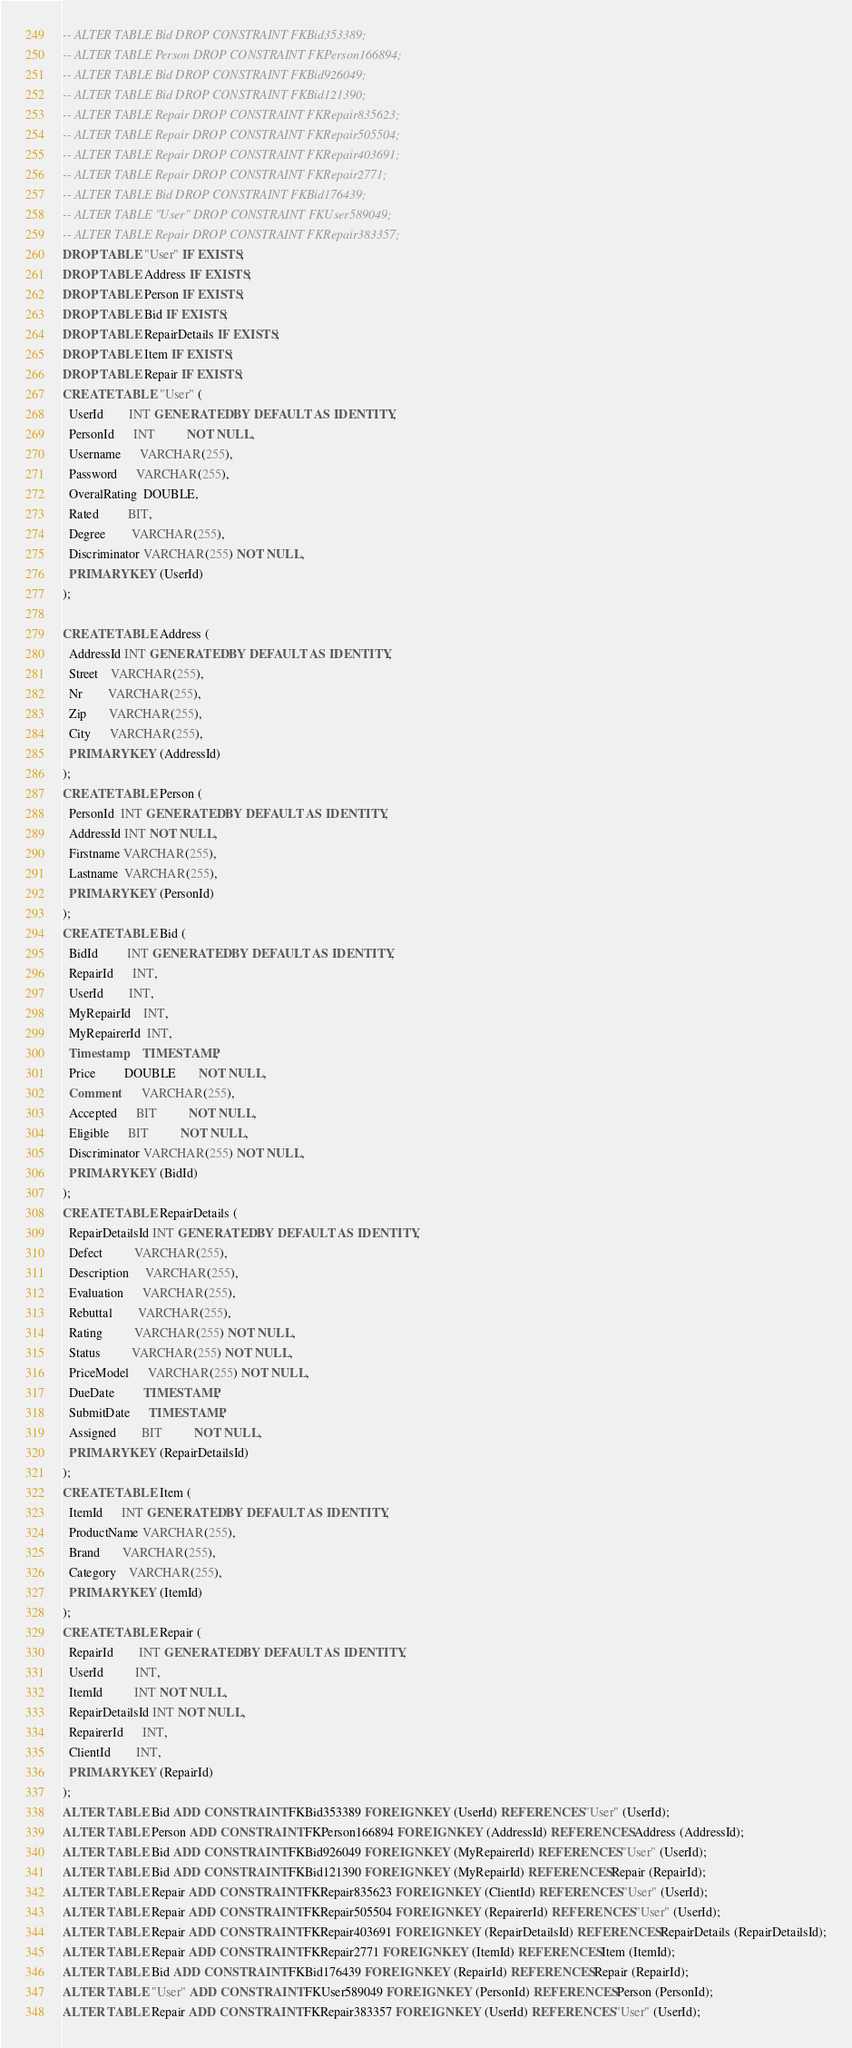Convert code to text. <code><loc_0><loc_0><loc_500><loc_500><_SQL_>-- ALTER TABLE Bid DROP CONSTRAINT FKBid353389;
-- ALTER TABLE Person DROP CONSTRAINT FKPerson166894;
-- ALTER TABLE Bid DROP CONSTRAINT FKBid926049;
-- ALTER TABLE Bid DROP CONSTRAINT FKBid121390;
-- ALTER TABLE Repair DROP CONSTRAINT FKRepair835623;
-- ALTER TABLE Repair DROP CONSTRAINT FKRepair505504;
-- ALTER TABLE Repair DROP CONSTRAINT FKRepair403691;
-- ALTER TABLE Repair DROP CONSTRAINT FKRepair2771;
-- ALTER TABLE Bid DROP CONSTRAINT FKBid176439;
-- ALTER TABLE "User" DROP CONSTRAINT FKUser589049;
-- ALTER TABLE Repair DROP CONSTRAINT FKRepair383357;
DROP TABLE "User" IF EXISTS;
DROP TABLE Address IF EXISTS;
DROP TABLE Person IF EXISTS;
DROP TABLE Bid IF EXISTS;
DROP TABLE RepairDetails IF EXISTS;
DROP TABLE Item IF EXISTS;
DROP TABLE Repair IF EXISTS;
CREATE TABLE "User" (
  UserId        INT GENERATED BY DEFAULT AS IDENTITY,
  PersonId      INT          NOT NULL,
  Username      VARCHAR(255),
  Password      VARCHAR(255),
  OveralRating  DOUBLE,
  Rated         BIT,
  Degree        VARCHAR(255),
  Discriminator VARCHAR(255) NOT NULL,
  PRIMARY KEY (UserId)
);

CREATE TABLE Address (
  AddressId INT GENERATED BY DEFAULT AS IDENTITY,
  Street    VARCHAR(255),
  Nr        VARCHAR(255),
  Zip       VARCHAR(255),
  City      VARCHAR(255),
  PRIMARY KEY (AddressId)
);
CREATE TABLE Person (
  PersonId  INT GENERATED BY DEFAULT AS IDENTITY,
  AddressId INT NOT NULL,
  Firstname VARCHAR(255),
  Lastname  VARCHAR(255),
  PRIMARY KEY (PersonId)
);
CREATE TABLE Bid (
  BidId         INT GENERATED BY DEFAULT AS IDENTITY,
  RepairId      INT,
  UserId        INT,
  MyRepairId    INT,
  MyRepairerId  INT,
  Timestamp     TIMESTAMP,
  Price         DOUBLE       NOT NULL,
  Comment       VARCHAR(255),
  Accepted      BIT          NOT NULL,
  Eligible      BIT          NOT NULL,
  Discriminator VARCHAR(255) NOT NULL,
  PRIMARY KEY (BidId)
);
CREATE TABLE RepairDetails (
  RepairDetailsId INT GENERATED BY DEFAULT AS IDENTITY,
  Defect          VARCHAR(255),
  Description     VARCHAR(255),
  Evaluation      VARCHAR(255),
  Rebuttal        VARCHAR(255),
  Rating          VARCHAR(255) NOT NULL,
  Status          VARCHAR(255) NOT NULL,
  PriceModel      VARCHAR(255) NOT NULL,
  DueDate         TIMESTAMP,
  SubmitDate      TIMESTAMP,
  Assigned        BIT          NOT NULL,
  PRIMARY KEY (RepairDetailsId)
);
CREATE TABLE Item (
  ItemId      INT GENERATED BY DEFAULT AS IDENTITY,
  ProductName VARCHAR(255),
  Brand       VARCHAR(255),
  Category    VARCHAR(255),
  PRIMARY KEY (ItemId)
);
CREATE TABLE Repair (
  RepairId        INT GENERATED BY DEFAULT AS IDENTITY,
  UserId          INT,
  ItemId          INT NOT NULL,
  RepairDetailsId INT NOT NULL,
  RepairerId      INT,
  ClientId        INT,
  PRIMARY KEY (RepairId)
);
ALTER TABLE Bid ADD CONSTRAINT FKBid353389 FOREIGN KEY (UserId) REFERENCES "User" (UserId);
ALTER TABLE Person ADD CONSTRAINT FKPerson166894 FOREIGN KEY (AddressId) REFERENCES Address (AddressId);
ALTER TABLE Bid ADD CONSTRAINT FKBid926049 FOREIGN KEY (MyRepairerId) REFERENCES "User" (UserId);
ALTER TABLE Bid ADD CONSTRAINT FKBid121390 FOREIGN KEY (MyRepairId) REFERENCES Repair (RepairId);
ALTER TABLE Repair ADD CONSTRAINT FKRepair835623 FOREIGN KEY (ClientId) REFERENCES "User" (UserId);
ALTER TABLE Repair ADD CONSTRAINT FKRepair505504 FOREIGN KEY (RepairerId) REFERENCES "User" (UserId);
ALTER TABLE Repair ADD CONSTRAINT FKRepair403691 FOREIGN KEY (RepairDetailsId) REFERENCES RepairDetails (RepairDetailsId);
ALTER TABLE Repair ADD CONSTRAINT FKRepair2771 FOREIGN KEY (ItemId) REFERENCES Item (ItemId);
ALTER TABLE Bid ADD CONSTRAINT FKBid176439 FOREIGN KEY (RepairId) REFERENCES Repair (RepairId);
ALTER TABLE "User" ADD CONSTRAINT FKUser589049 FOREIGN KEY (PersonId) REFERENCES Person (PersonId);
ALTER TABLE Repair ADD CONSTRAINT FKRepair383357 FOREIGN KEY (UserId) REFERENCES "User" (UserId);
</code> 